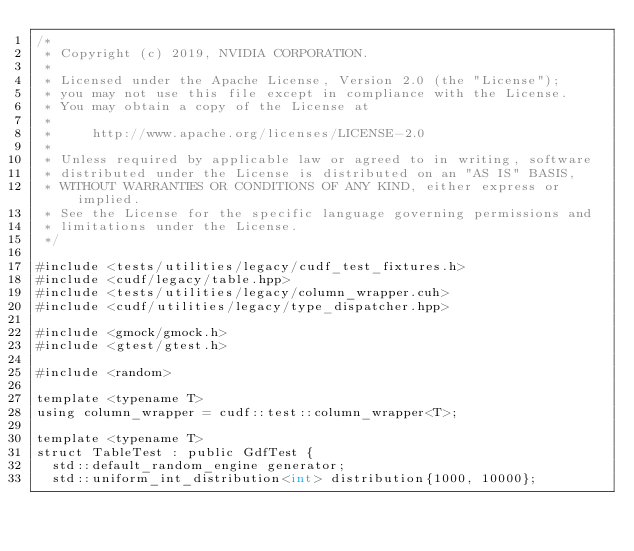<code> <loc_0><loc_0><loc_500><loc_500><_Cuda_>/*
 * Copyright (c) 2019, NVIDIA CORPORATION.
 *
 * Licensed under the Apache License, Version 2.0 (the "License");
 * you may not use this file except in compliance with the License.
 * You may obtain a copy of the License at
 *
 *     http://www.apache.org/licenses/LICENSE-2.0
 *
 * Unless required by applicable law or agreed to in writing, software
 * distributed under the License is distributed on an "AS IS" BASIS,
 * WITHOUT WARRANTIES OR CONDITIONS OF ANY KIND, either express or implied.
 * See the License for the specific language governing permissions and
 * limitations under the License.
 */

#include <tests/utilities/legacy/cudf_test_fixtures.h>
#include <cudf/legacy/table.hpp>
#include <tests/utilities/legacy/column_wrapper.cuh>
#include <cudf/utilities/legacy/type_dispatcher.hpp>

#include <gmock/gmock.h>
#include <gtest/gtest.h>

#include <random>

template <typename T>
using column_wrapper = cudf::test::column_wrapper<T>;

template <typename T>
struct TableTest : public GdfTest {
  std::default_random_engine generator;
  std::uniform_int_distribution<int> distribution{1000, 10000};</code> 